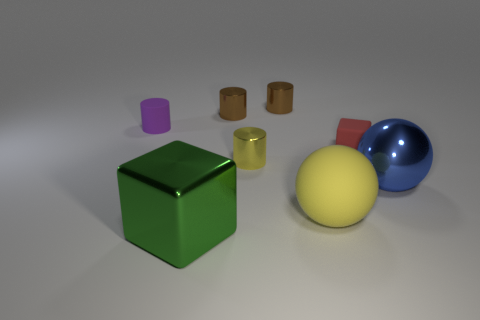Subtract 2 cylinders. How many cylinders are left? 2 Add 1 red objects. How many objects exist? 9 Subtract all cyan cylinders. Subtract all yellow spheres. How many cylinders are left? 4 Subtract all blocks. How many objects are left? 6 Subtract all small purple matte cylinders. Subtract all brown shiny cylinders. How many objects are left? 5 Add 3 cylinders. How many cylinders are left? 7 Add 2 big yellow cylinders. How many big yellow cylinders exist? 2 Subtract 0 green cylinders. How many objects are left? 8 